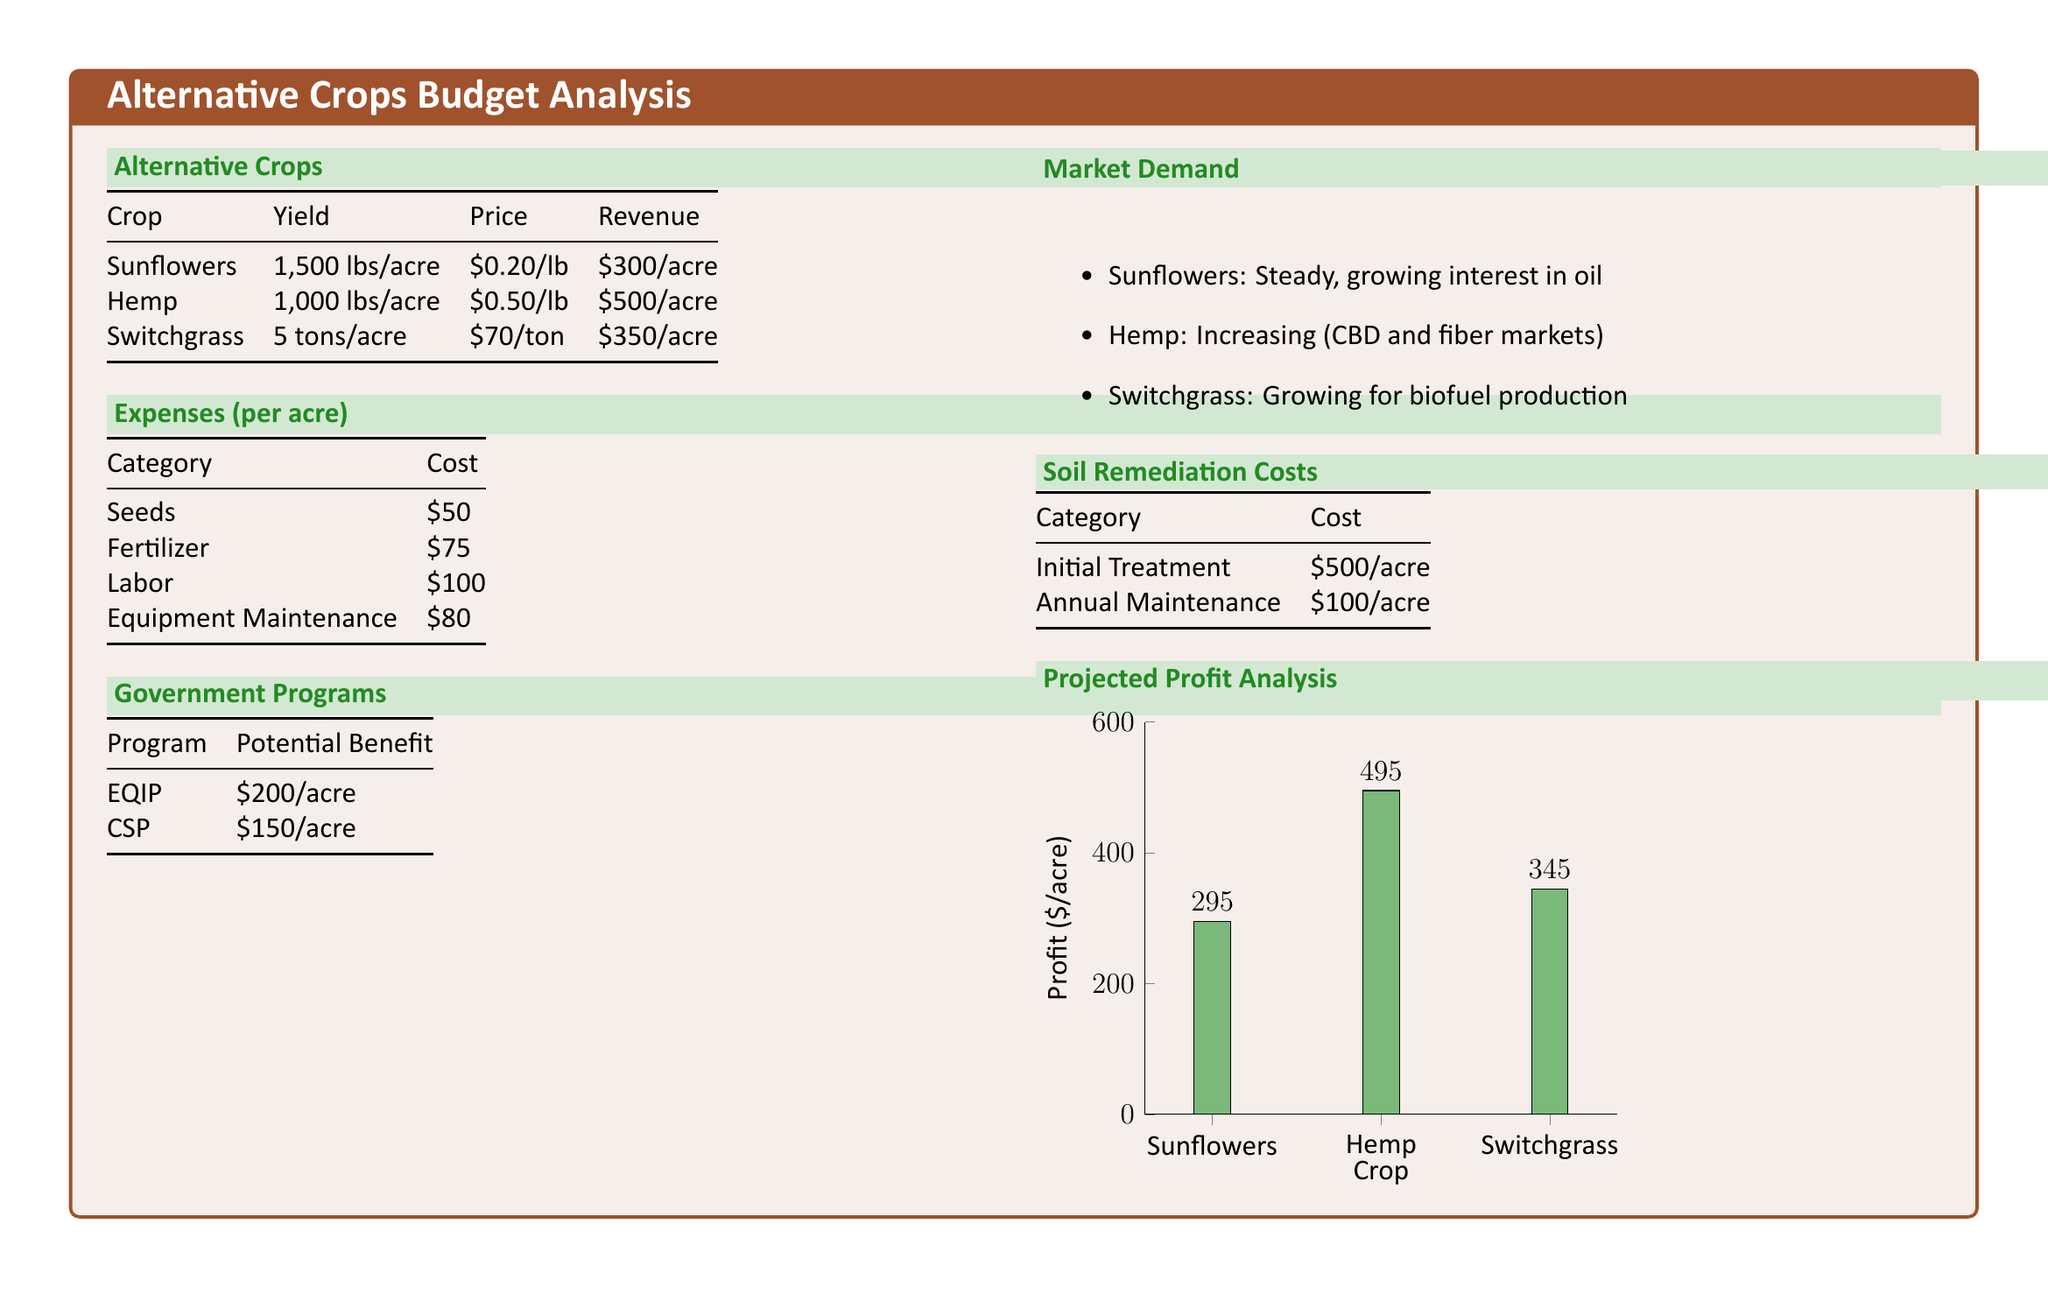What is the yield of sunflowers per acre? The document states that the yield of sunflowers is 1,500 lbs/acre.
Answer: 1,500 lbs/acre What is the price of hemp per pound? The price of hemp is listed as $0.50/lb in the document.
Answer: $0.50/lb What is the revenue generated from switchgrass per acre? The revenue from switchgrass is provided as $350/acre.
Answer: $350/acre What is the total cost for soil remediation (initial treatment + annual maintenance) per acre? The total cost includes initial treatment of $500/acre and annual maintenance of $100/acre, totaling $600/acre.
Answer: $600/acre What is the potential benefit from the EQIP government program? The EQIP program provides a potential benefit of $200/acre, as mentioned in the document.
Answer: $200/acre Which crop has the highest projected profit? The projected profit for hemp is the highest at $495/acre, according to the analysis.
Answer: Hemp What is the cost of seeds per acre? The document lists the cost of seeds as $50 per acre.
Answer: $50 What is the profit from sunflowers after deducting expenses? The profit from sunflowers is calculated as $295/acre in the document.
Answer: $295 What is the expected market demand for hemp? The market demand for hemp is noted as increasing for CBD and fiber markets.
Answer: Increasing 